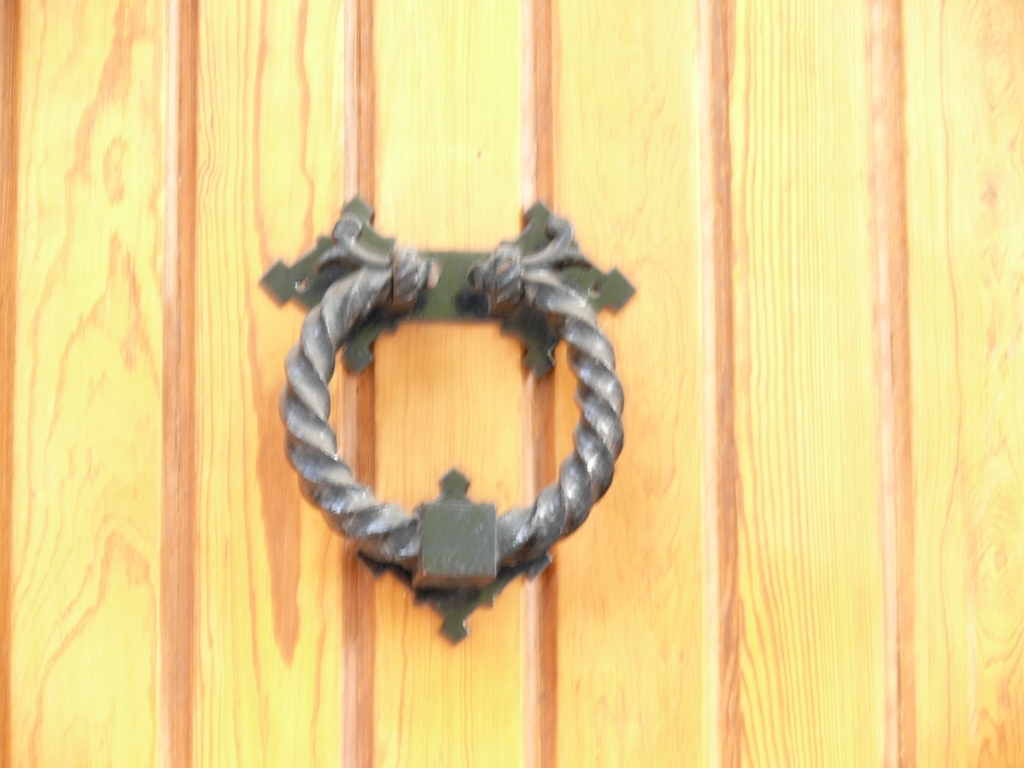Where would you typically find this item being used? This type of door knocker is typically found on the front doors of homes, particularly those that wish to convey a sense of history and tradition. It could belong to a house that has a classical or period-style architecture. 